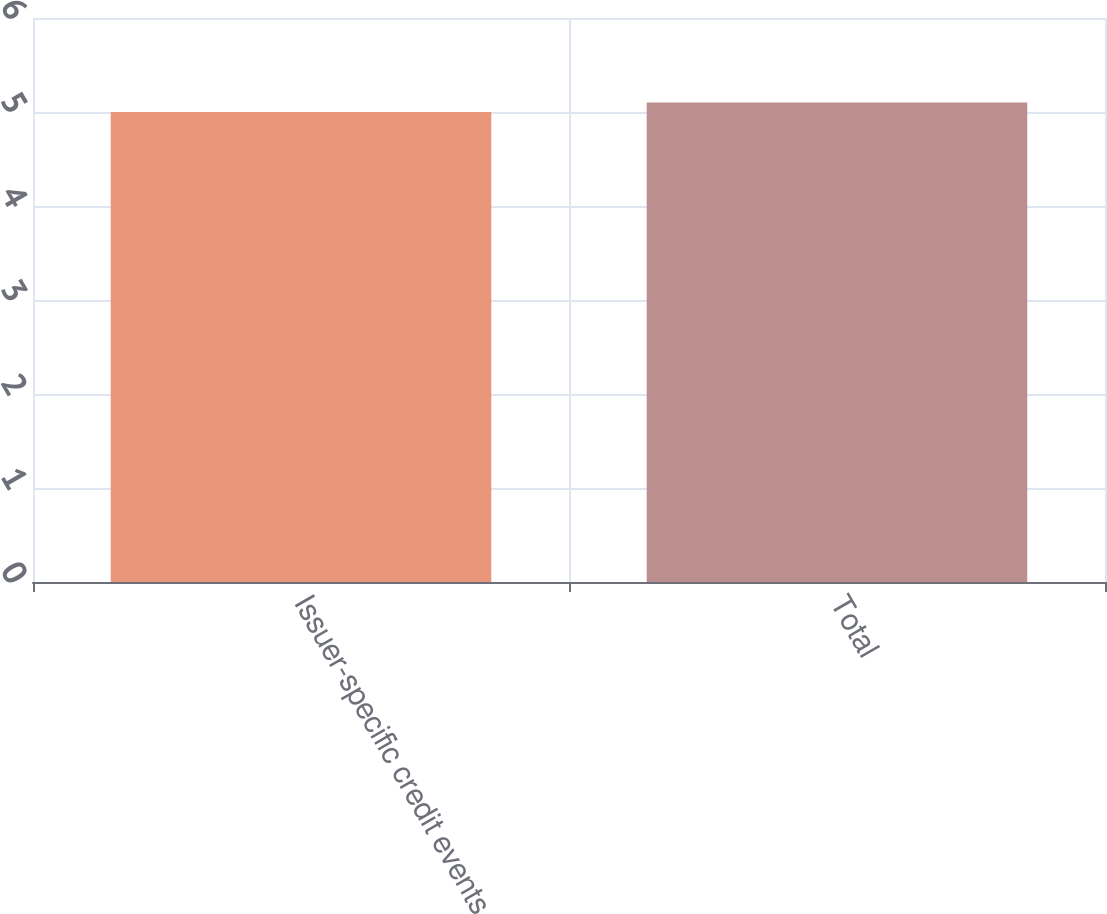<chart> <loc_0><loc_0><loc_500><loc_500><bar_chart><fcel>Issuer-specific credit events<fcel>Total<nl><fcel>5<fcel>5.1<nl></chart> 